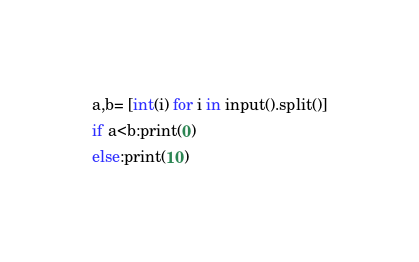<code> <loc_0><loc_0><loc_500><loc_500><_C#_>a,b= [int(i) for i in input().split()]
if a<b:print(0)
else:print(10)</code> 